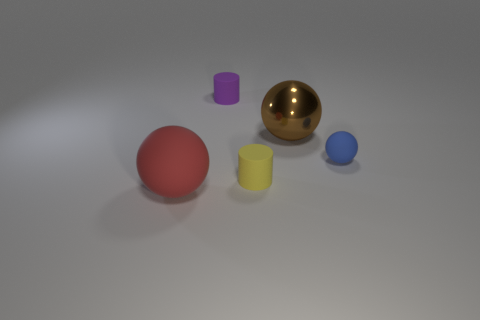How does the lighting in the image affect the appearance of the objects? The lighting in the image appears to be coming from above, casting subtle shadows directly underneath the objects. This lighting enhances the objects' three-dimensional appearance and emphasizes their colors. The golden sphere, in particular, reflects light, highlighting its shiny material compared to the more matte surfaces of the other objects. 